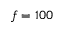<formula> <loc_0><loc_0><loc_500><loc_500>f = 1 0 0</formula> 